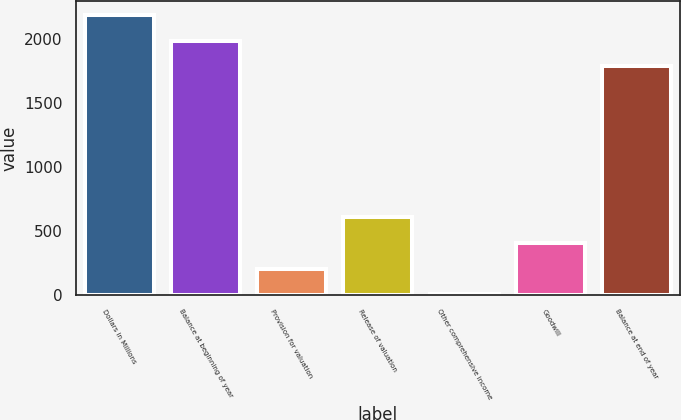Convert chart. <chart><loc_0><loc_0><loc_500><loc_500><bar_chart><fcel>Dollars in Millions<fcel>Balance at beginning of year<fcel>Provision for valuation<fcel>Release of valuation<fcel>Other comprehensive income<fcel>Goodwill<fcel>Balance at end of year<nl><fcel>2191.2<fcel>1991.1<fcel>208.1<fcel>608.3<fcel>8<fcel>408.2<fcel>1791<nl></chart> 